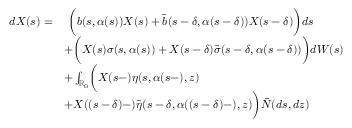<formula> <loc_0><loc_0><loc_500><loc_500>\begin{array} { r l } { d X ( s ) = } & { \ \left ( b ( s , \alpha ( s ) ) X ( s ) + \bar { b } ( s - \delta , \alpha ( s - \delta ) ) X ( s - \delta ) \right ) d s } \\ & { + \left ( X ( s ) \sigma ( s , \alpha ( s ) ) + X ( s - \delta ) \bar { \sigma } ( s - \delta , \alpha ( s - \delta ) ) \right ) d W ( s ) } \\ & { + \int _ { \mathbb { R } _ { 0 } } \left ( X ( s - ) \eta ( s , \alpha ( s - ) , z ) } \\ & { + X ( ( s - \delta ) - ) \bar { \eta } ( s - \delta , \alpha ( ( s - \delta ) - ) , z ) \right ) \tilde { N } ( d s , d z ) } \end{array}</formula> 